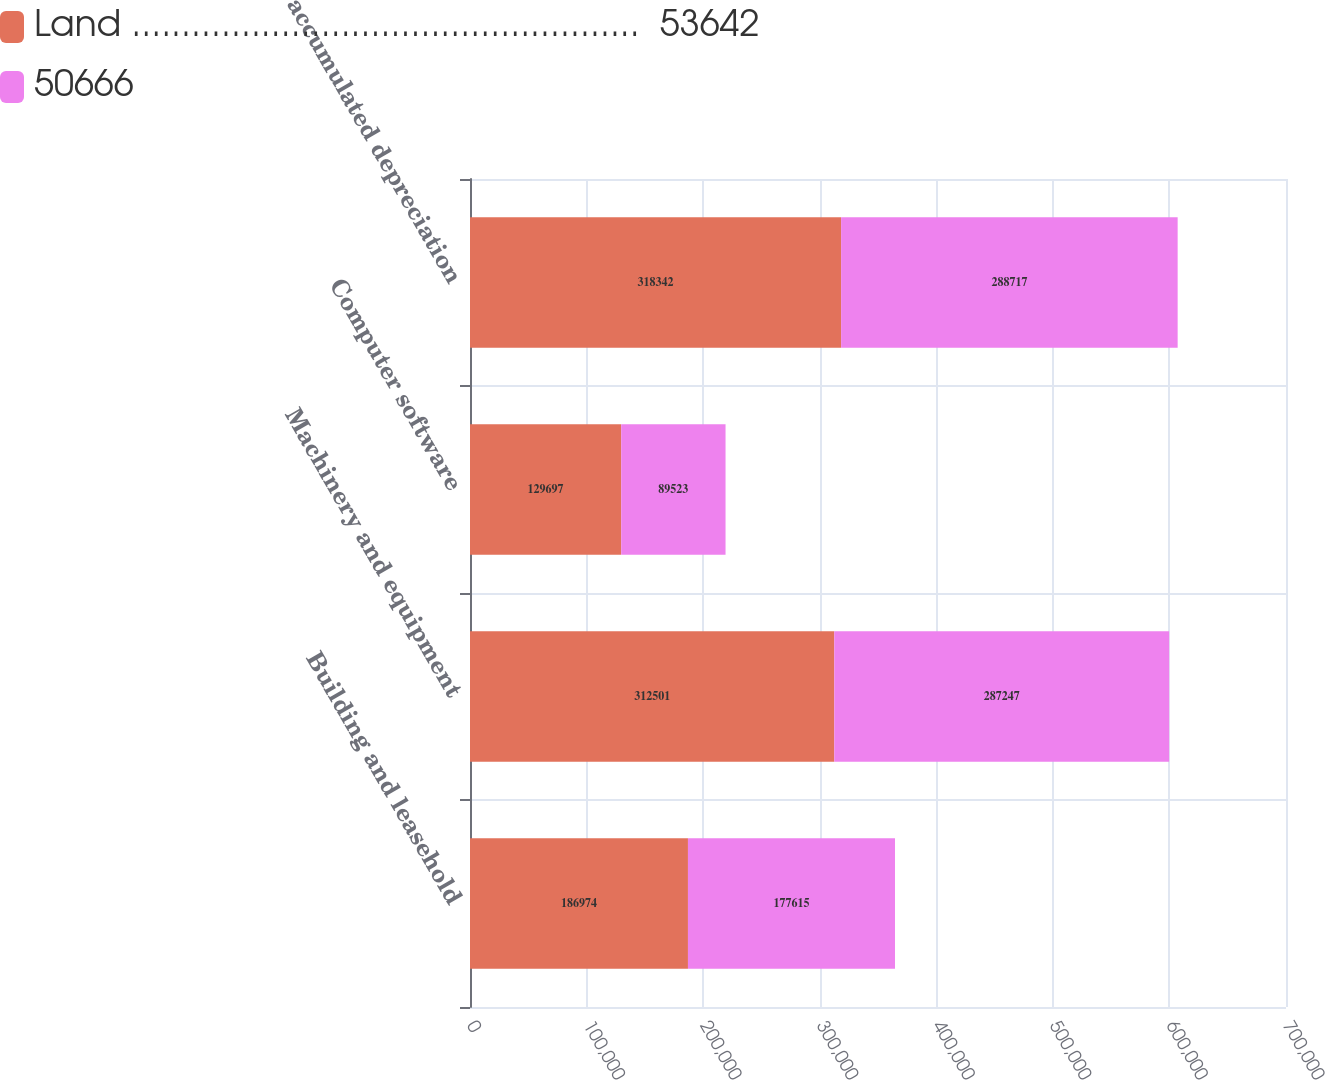<chart> <loc_0><loc_0><loc_500><loc_500><stacked_bar_chart><ecel><fcel>Building and leasehold<fcel>Machinery and equipment<fcel>Computer software<fcel>Less accumulated depreciation<nl><fcel>Land ...................................................  53642<fcel>186974<fcel>312501<fcel>129697<fcel>318342<nl><fcel>50666<fcel>177615<fcel>287247<fcel>89523<fcel>288717<nl></chart> 